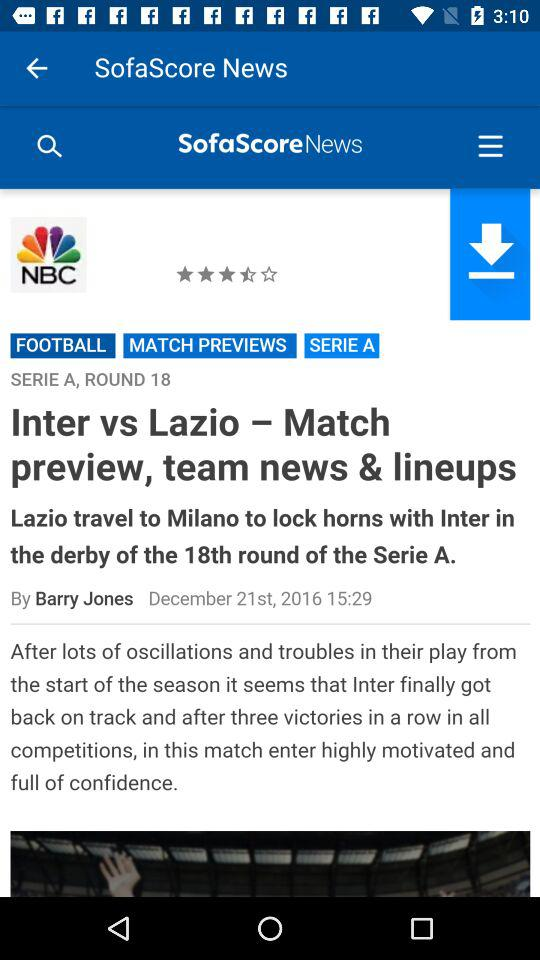Who is the writer of the news? The writer of the news is Barry Jones. 